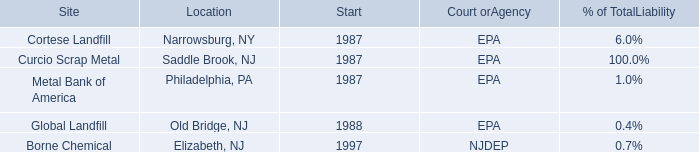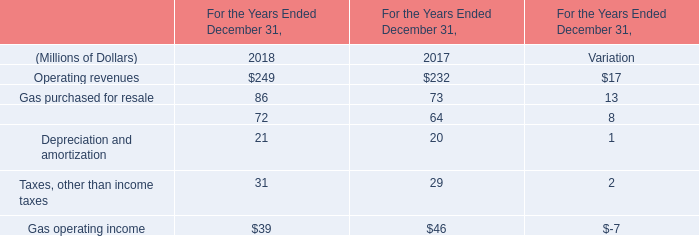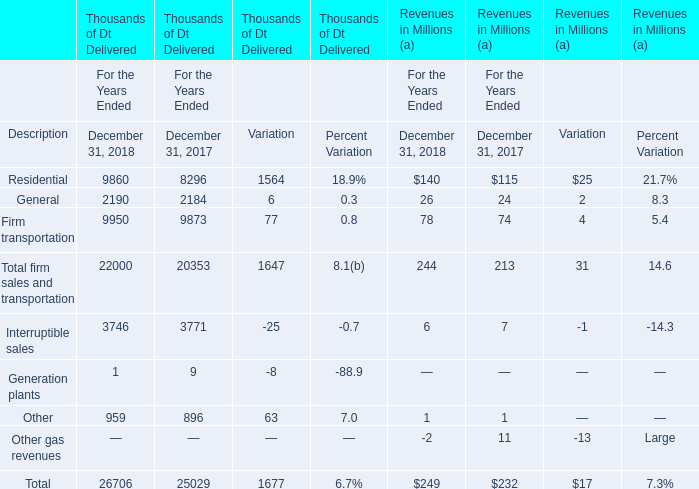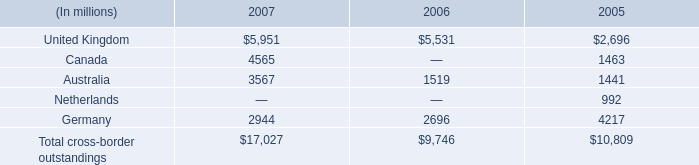If other operations and maintenance develops with the same increasing rate in 2018, what will it reach in 2019? (in million) 
Computations: (72 * (1 + (8 / 64)))
Answer: 81.0. 